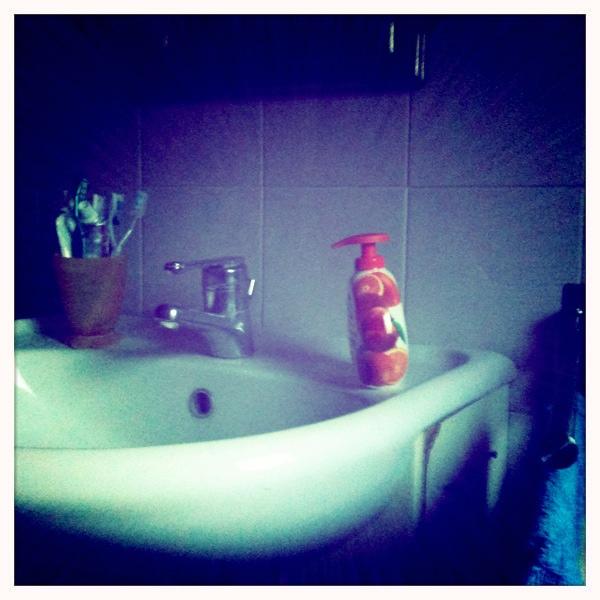What is in the brown cup?
Give a very brief answer. Toothbrushes. Does water come out of the pink thing?
Short answer required. No. Is there a toothbrush glass on the sink?
Be succinct. Yes. 